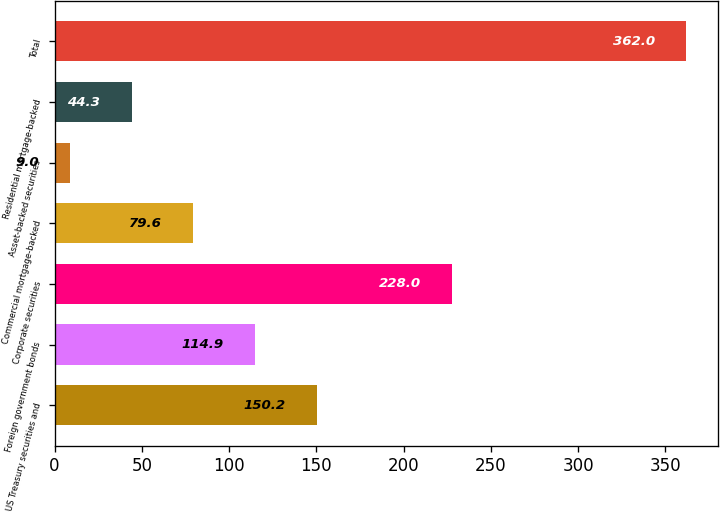Convert chart. <chart><loc_0><loc_0><loc_500><loc_500><bar_chart><fcel>US Treasury securities and<fcel>Foreign government bonds<fcel>Corporate securities<fcel>Commercial mortgage-backed<fcel>Asset-backed securities<fcel>Residential mortgage-backed<fcel>Total<nl><fcel>150.2<fcel>114.9<fcel>228<fcel>79.6<fcel>9<fcel>44.3<fcel>362<nl></chart> 